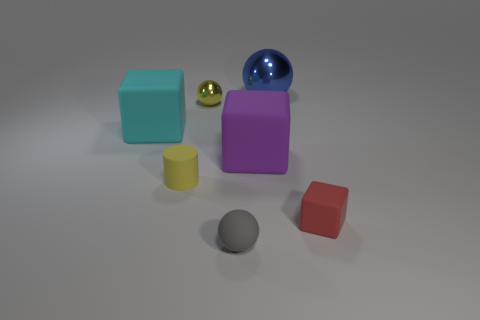Add 3 blue metallic objects. How many objects exist? 10 Subtract all balls. How many objects are left? 4 Add 5 big blocks. How many big blocks are left? 7 Add 6 tiny cyan things. How many tiny cyan things exist? 6 Subtract 1 blue spheres. How many objects are left? 6 Subtract all red cubes. Subtract all blue metallic things. How many objects are left? 5 